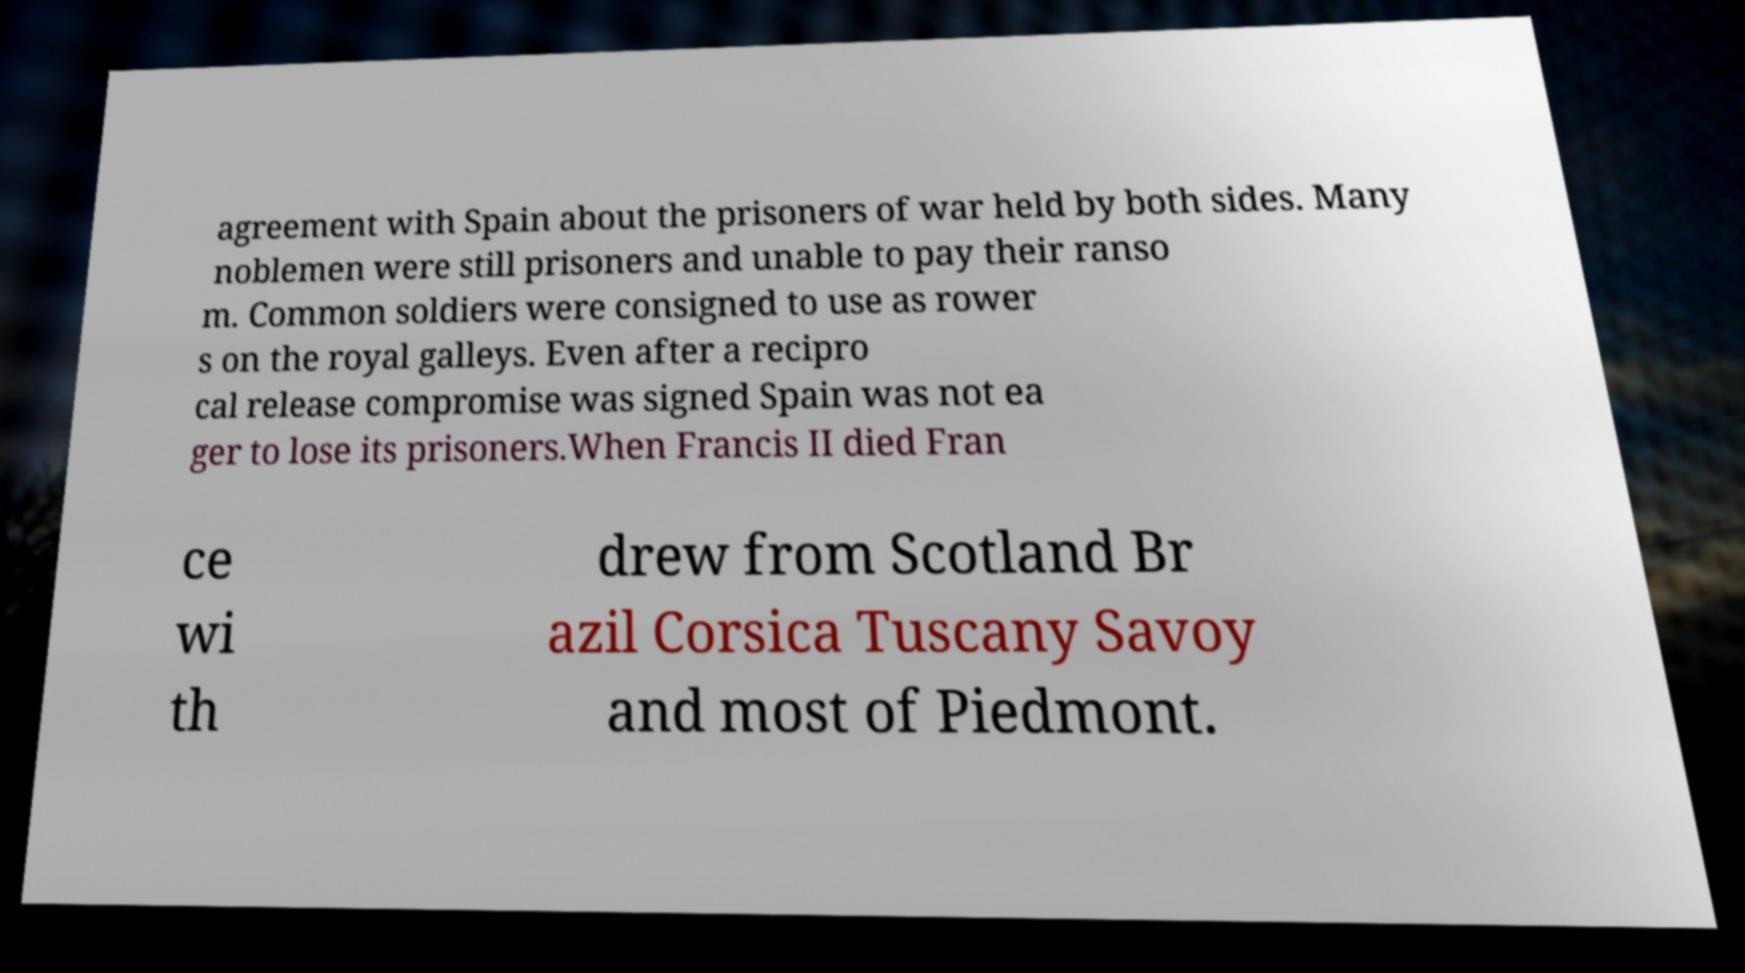Could you assist in decoding the text presented in this image and type it out clearly? agreement with Spain about the prisoners of war held by both sides. Many noblemen were still prisoners and unable to pay their ranso m. Common soldiers were consigned to use as rower s on the royal galleys. Even after a recipro cal release compromise was signed Spain was not ea ger to lose its prisoners.When Francis II died Fran ce wi th drew from Scotland Br azil Corsica Tuscany Savoy and most of Piedmont. 